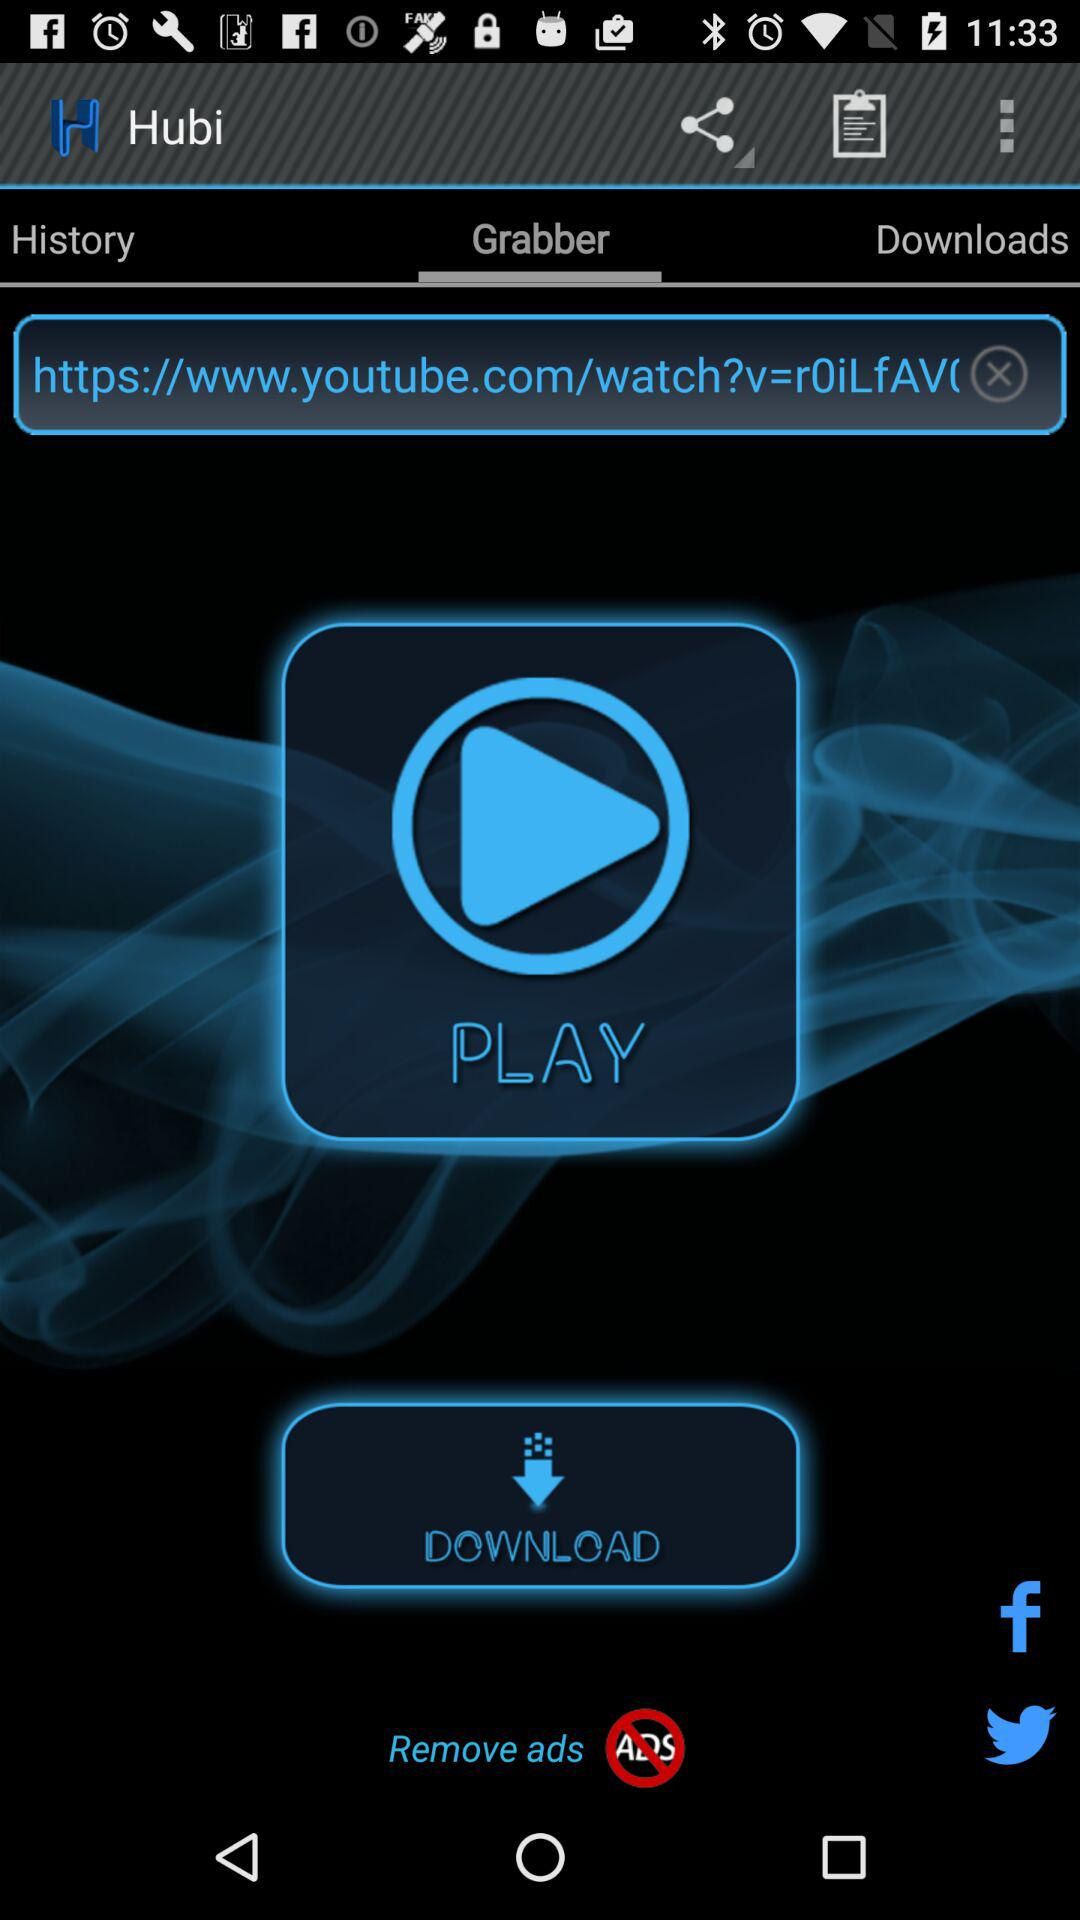What is the application name? The application name is "Hubi". 